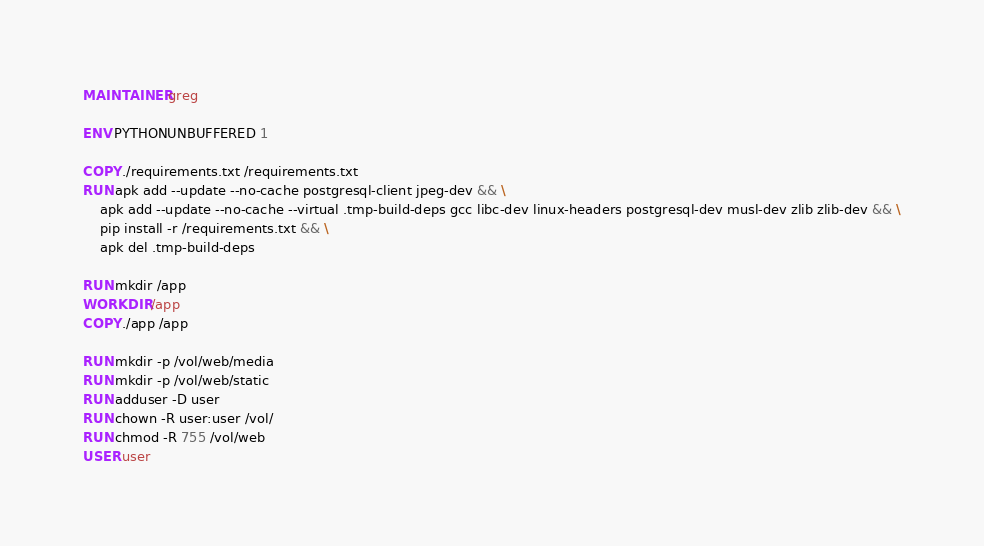<code> <loc_0><loc_0><loc_500><loc_500><_Dockerfile_>MAINTAINER greg

ENV PYTHONUNBUFFERED 1

COPY ./requirements.txt /requirements.txt
RUN apk add --update --no-cache postgresql-client jpeg-dev && \
    apk add --update --no-cache --virtual .tmp-build-deps gcc libc-dev linux-headers postgresql-dev musl-dev zlib zlib-dev && \
    pip install -r /requirements.txt && \
    apk del .tmp-build-deps

RUN mkdir /app
WORKDIR /app
COPY ./app /app

RUN mkdir -p /vol/web/media
RUN mkdir -p /vol/web/static
RUN adduser -D user
RUN chown -R user:user /vol/
RUN chmod -R 755 /vol/web
USER user
</code> 